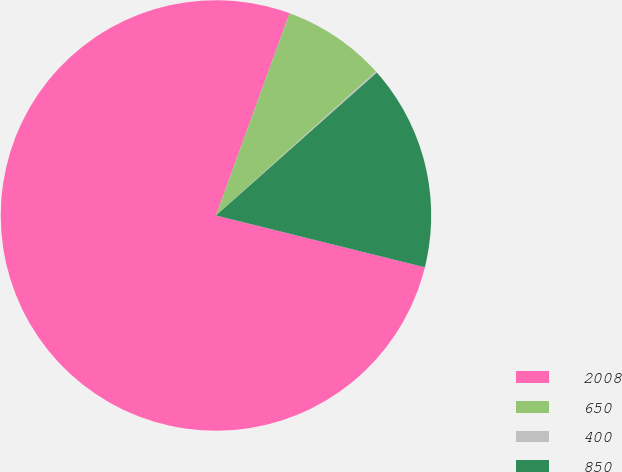Convert chart. <chart><loc_0><loc_0><loc_500><loc_500><pie_chart><fcel>2008<fcel>650<fcel>400<fcel>850<nl><fcel>76.68%<fcel>7.77%<fcel>0.11%<fcel>15.43%<nl></chart> 